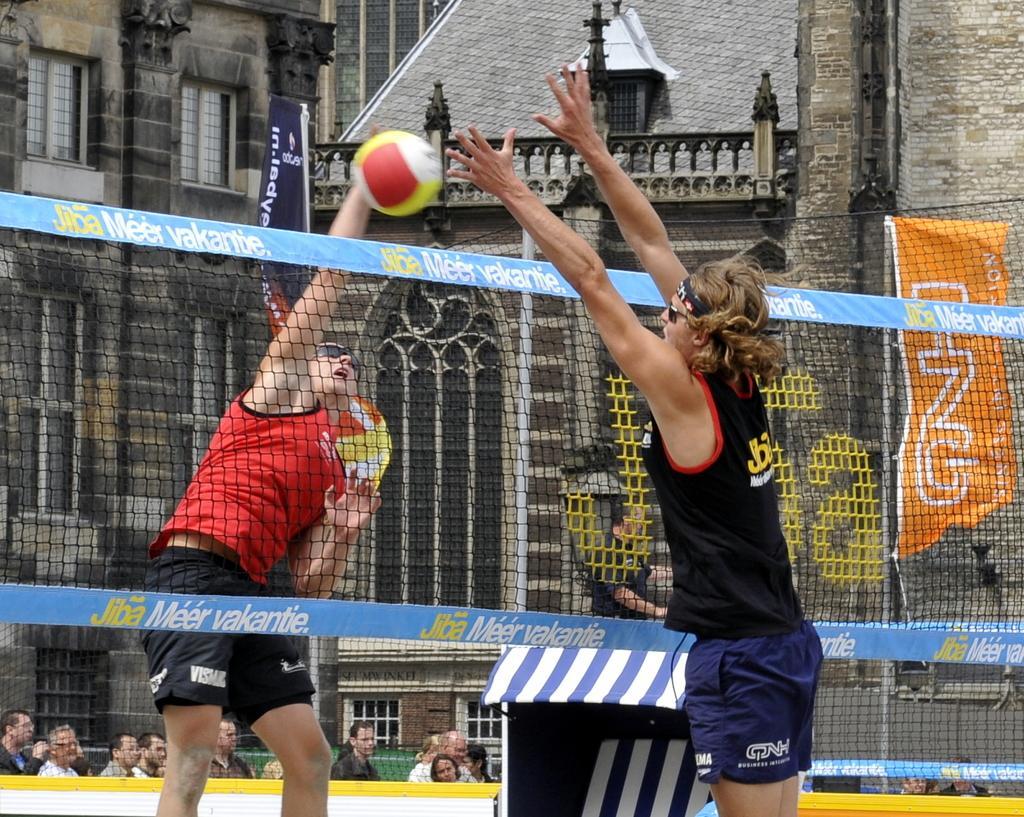Can you describe this image briefly? In this image we can see two people playing a game. In the center there is a net and we can see a ball. In the background there are buildings and flags. At the bottom there is crowd. 